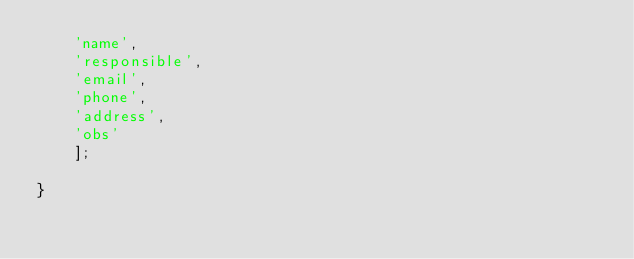<code> <loc_0><loc_0><loc_500><loc_500><_PHP_>    'name',
    'responsible',
    'email',
    'phone',
    'address',
    'obs'
    ];

}
</code> 